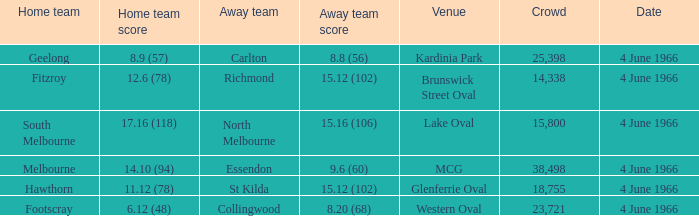What is the typical audience size for the away team that scored 38498.0. 